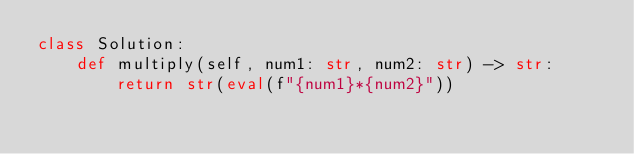Convert code to text. <code><loc_0><loc_0><loc_500><loc_500><_Python_>class Solution:
    def multiply(self, num1: str, num2: str) -> str:
        return str(eval(f"{num1}*{num2}"))</code> 